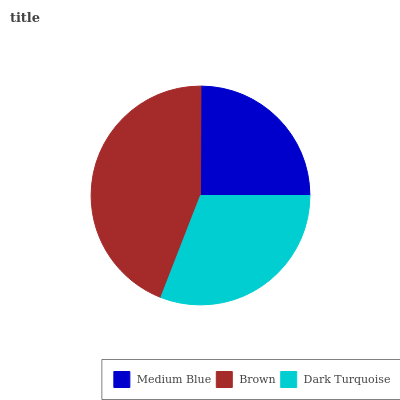Is Medium Blue the minimum?
Answer yes or no. Yes. Is Brown the maximum?
Answer yes or no. Yes. Is Dark Turquoise the minimum?
Answer yes or no. No. Is Dark Turquoise the maximum?
Answer yes or no. No. Is Brown greater than Dark Turquoise?
Answer yes or no. Yes. Is Dark Turquoise less than Brown?
Answer yes or no. Yes. Is Dark Turquoise greater than Brown?
Answer yes or no. No. Is Brown less than Dark Turquoise?
Answer yes or no. No. Is Dark Turquoise the high median?
Answer yes or no. Yes. Is Dark Turquoise the low median?
Answer yes or no. Yes. Is Brown the high median?
Answer yes or no. No. Is Medium Blue the low median?
Answer yes or no. No. 